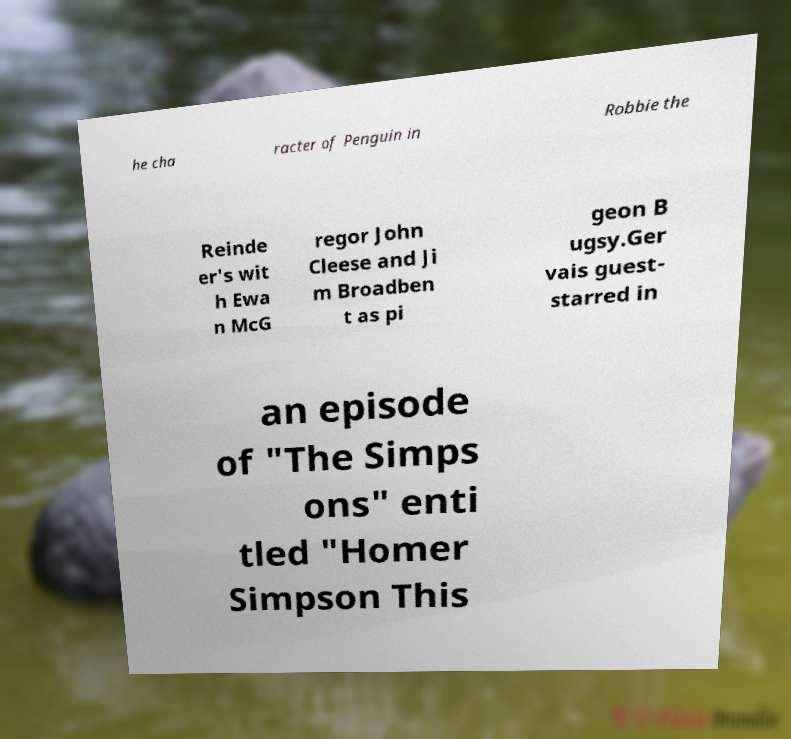Could you assist in decoding the text presented in this image and type it out clearly? he cha racter of Penguin in Robbie the Reinde er's wit h Ewa n McG regor John Cleese and Ji m Broadben t as pi geon B ugsy.Ger vais guest- starred in an episode of "The Simps ons" enti tled "Homer Simpson This 